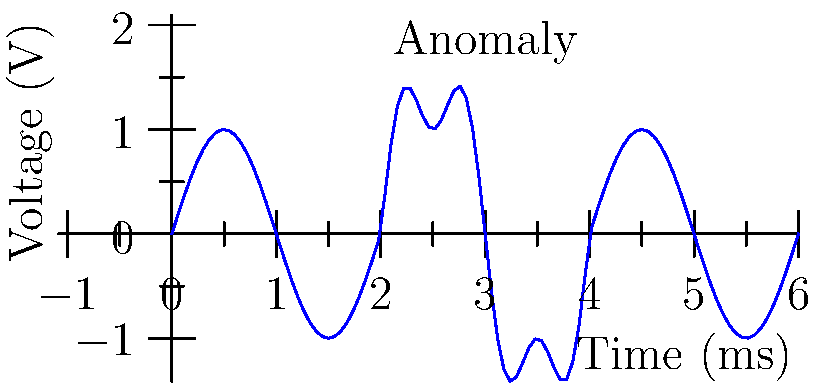In the oscilloscope reading shown above, a voltage-time waveform is displayed for a signal over a 6 ms period. What type of signal anomaly is present, and at approximately what time does it occur? To interpret this voltage-time waveform and identify the signal anomaly, let's follow these steps:

1. Observe the overall waveform:
   The signal appears to be sinusoidal for the most part, with a consistent amplitude and frequency.

2. Identify the anomaly:
   There's a noticeable change in the waveform between 2 ms and 4 ms. The signal amplitude increases and the waveform becomes more complex during this period.

3. Analyze the anomaly:
   The anomalous section shows:
   a) Increased amplitude: The peak-to-peak voltage is larger.
   b) Higher frequency components: The waveform is not a simple sine wave, suggesting the presence of harmonics.

4. Classify the anomaly:
   This type of anomaly, where additional frequency components appear temporarily in a signal, is known as a "harmonic distortion" or "harmonic interference."

5. Determine the timing:
   The anomaly begins at approximately 2 ms and ends at approximately 4 ms.

6. Interpret in context:
   For a data analyst investigating financial data, such an anomaly could represent a period of unusual trading activity or data manipulation, where the normal pattern of financial transactions is temporarily altered.
Answer: Harmonic distortion at ~2 ms 